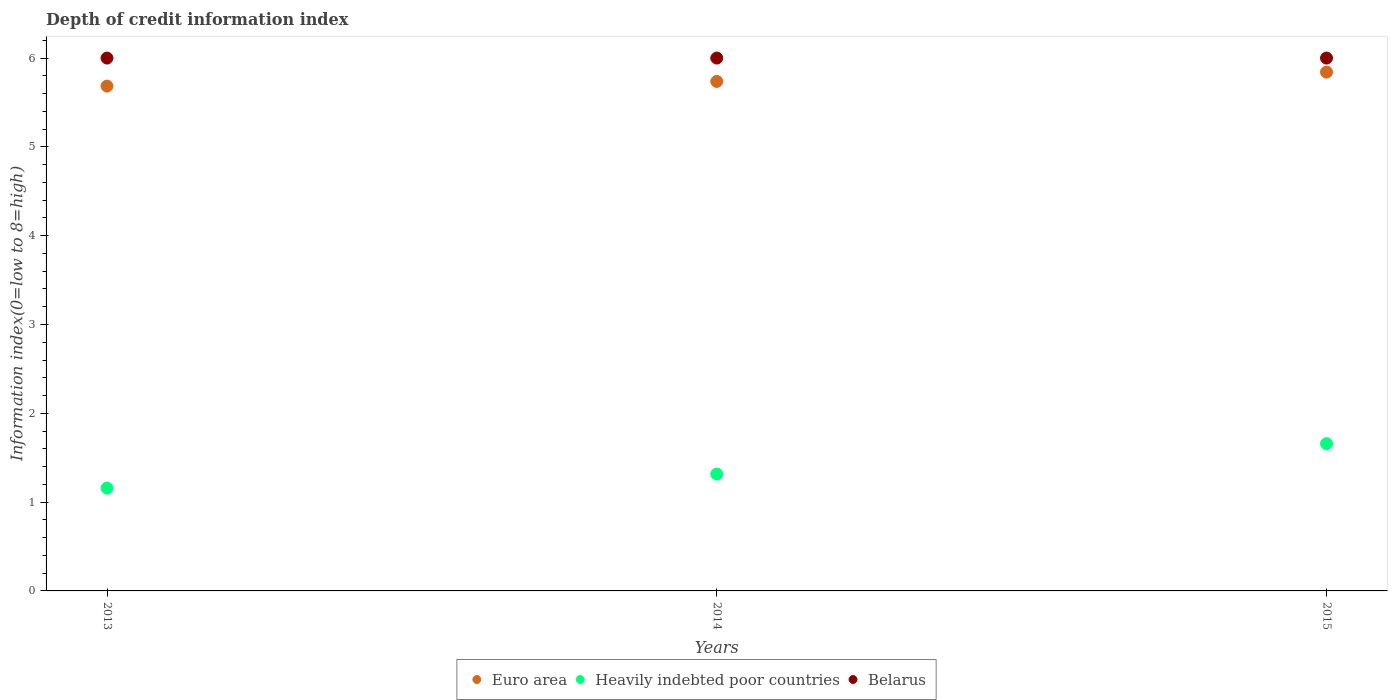How many different coloured dotlines are there?
Provide a short and direct response. 3. What is the information index in Euro area in 2015?
Keep it short and to the point. 5.84. Across all years, what is the maximum information index in Euro area?
Your response must be concise. 5.84. Across all years, what is the minimum information index in Euro area?
Your answer should be very brief. 5.68. In which year was the information index in Euro area maximum?
Your response must be concise. 2015. In which year was the information index in Heavily indebted poor countries minimum?
Offer a terse response. 2013. What is the total information index in Euro area in the graph?
Offer a very short reply. 17.26. What is the difference between the information index in Euro area in 2013 and that in 2014?
Your response must be concise. -0.05. What is the difference between the information index in Heavily indebted poor countries in 2015 and the information index in Belarus in 2014?
Offer a terse response. -4.34. In the year 2013, what is the difference between the information index in Heavily indebted poor countries and information index in Euro area?
Offer a terse response. -4.53. What is the ratio of the information index in Heavily indebted poor countries in 2013 to that in 2015?
Offer a terse response. 0.7. Is the information index in Euro area in 2013 less than that in 2014?
Keep it short and to the point. Yes. What is the difference between the highest and the lowest information index in Euro area?
Make the answer very short. 0.16. In how many years, is the information index in Euro area greater than the average information index in Euro area taken over all years?
Provide a succinct answer. 1. Is the sum of the information index in Heavily indebted poor countries in 2013 and 2015 greater than the maximum information index in Euro area across all years?
Ensure brevity in your answer.  No. Is it the case that in every year, the sum of the information index in Belarus and information index in Euro area  is greater than the information index in Heavily indebted poor countries?
Provide a succinct answer. Yes. Does the information index in Belarus monotonically increase over the years?
Provide a short and direct response. No. Is the information index in Heavily indebted poor countries strictly less than the information index in Euro area over the years?
Provide a succinct answer. Yes. How many dotlines are there?
Ensure brevity in your answer.  3. How many years are there in the graph?
Keep it short and to the point. 3. Are the values on the major ticks of Y-axis written in scientific E-notation?
Offer a terse response. No. Does the graph contain any zero values?
Give a very brief answer. No. Does the graph contain grids?
Keep it short and to the point. No. What is the title of the graph?
Offer a very short reply. Depth of credit information index. Does "Caribbean small states" appear as one of the legend labels in the graph?
Provide a succinct answer. No. What is the label or title of the X-axis?
Give a very brief answer. Years. What is the label or title of the Y-axis?
Give a very brief answer. Information index(0=low to 8=high). What is the Information index(0=low to 8=high) in Euro area in 2013?
Offer a terse response. 5.68. What is the Information index(0=low to 8=high) in Heavily indebted poor countries in 2013?
Your answer should be compact. 1.16. What is the Information index(0=low to 8=high) of Belarus in 2013?
Offer a terse response. 6. What is the Information index(0=low to 8=high) in Euro area in 2014?
Offer a very short reply. 5.74. What is the Information index(0=low to 8=high) in Heavily indebted poor countries in 2014?
Offer a terse response. 1.32. What is the Information index(0=low to 8=high) of Belarus in 2014?
Your answer should be very brief. 6. What is the Information index(0=low to 8=high) of Euro area in 2015?
Give a very brief answer. 5.84. What is the Information index(0=low to 8=high) of Heavily indebted poor countries in 2015?
Make the answer very short. 1.66. Across all years, what is the maximum Information index(0=low to 8=high) of Euro area?
Ensure brevity in your answer.  5.84. Across all years, what is the maximum Information index(0=low to 8=high) of Heavily indebted poor countries?
Make the answer very short. 1.66. Across all years, what is the maximum Information index(0=low to 8=high) of Belarus?
Ensure brevity in your answer.  6. Across all years, what is the minimum Information index(0=low to 8=high) in Euro area?
Give a very brief answer. 5.68. Across all years, what is the minimum Information index(0=low to 8=high) of Heavily indebted poor countries?
Ensure brevity in your answer.  1.16. Across all years, what is the minimum Information index(0=low to 8=high) of Belarus?
Your response must be concise. 6. What is the total Information index(0=low to 8=high) in Euro area in the graph?
Your answer should be very brief. 17.26. What is the total Information index(0=low to 8=high) in Heavily indebted poor countries in the graph?
Provide a short and direct response. 4.13. What is the difference between the Information index(0=low to 8=high) in Euro area in 2013 and that in 2014?
Provide a succinct answer. -0.05. What is the difference between the Information index(0=low to 8=high) in Heavily indebted poor countries in 2013 and that in 2014?
Make the answer very short. -0.16. What is the difference between the Information index(0=low to 8=high) of Belarus in 2013 and that in 2014?
Provide a short and direct response. 0. What is the difference between the Information index(0=low to 8=high) of Euro area in 2013 and that in 2015?
Offer a very short reply. -0.16. What is the difference between the Information index(0=low to 8=high) of Euro area in 2014 and that in 2015?
Offer a very short reply. -0.11. What is the difference between the Information index(0=low to 8=high) in Heavily indebted poor countries in 2014 and that in 2015?
Offer a very short reply. -0.34. What is the difference between the Information index(0=low to 8=high) of Euro area in 2013 and the Information index(0=low to 8=high) of Heavily indebted poor countries in 2014?
Give a very brief answer. 4.37. What is the difference between the Information index(0=low to 8=high) in Euro area in 2013 and the Information index(0=low to 8=high) in Belarus in 2014?
Make the answer very short. -0.32. What is the difference between the Information index(0=low to 8=high) in Heavily indebted poor countries in 2013 and the Information index(0=low to 8=high) in Belarus in 2014?
Your response must be concise. -4.84. What is the difference between the Information index(0=low to 8=high) in Euro area in 2013 and the Information index(0=low to 8=high) in Heavily indebted poor countries in 2015?
Ensure brevity in your answer.  4.03. What is the difference between the Information index(0=low to 8=high) of Euro area in 2013 and the Information index(0=low to 8=high) of Belarus in 2015?
Ensure brevity in your answer.  -0.32. What is the difference between the Information index(0=low to 8=high) in Heavily indebted poor countries in 2013 and the Information index(0=low to 8=high) in Belarus in 2015?
Provide a short and direct response. -4.84. What is the difference between the Information index(0=low to 8=high) in Euro area in 2014 and the Information index(0=low to 8=high) in Heavily indebted poor countries in 2015?
Keep it short and to the point. 4.08. What is the difference between the Information index(0=low to 8=high) in Euro area in 2014 and the Information index(0=low to 8=high) in Belarus in 2015?
Provide a short and direct response. -0.26. What is the difference between the Information index(0=low to 8=high) in Heavily indebted poor countries in 2014 and the Information index(0=low to 8=high) in Belarus in 2015?
Ensure brevity in your answer.  -4.68. What is the average Information index(0=low to 8=high) of Euro area per year?
Provide a short and direct response. 5.75. What is the average Information index(0=low to 8=high) of Heavily indebted poor countries per year?
Provide a short and direct response. 1.38. What is the average Information index(0=low to 8=high) in Belarus per year?
Keep it short and to the point. 6. In the year 2013, what is the difference between the Information index(0=low to 8=high) in Euro area and Information index(0=low to 8=high) in Heavily indebted poor countries?
Make the answer very short. 4.53. In the year 2013, what is the difference between the Information index(0=low to 8=high) of Euro area and Information index(0=low to 8=high) of Belarus?
Your response must be concise. -0.32. In the year 2013, what is the difference between the Information index(0=low to 8=high) in Heavily indebted poor countries and Information index(0=low to 8=high) in Belarus?
Offer a terse response. -4.84. In the year 2014, what is the difference between the Information index(0=low to 8=high) in Euro area and Information index(0=low to 8=high) in Heavily indebted poor countries?
Offer a terse response. 4.42. In the year 2014, what is the difference between the Information index(0=low to 8=high) in Euro area and Information index(0=low to 8=high) in Belarus?
Provide a succinct answer. -0.26. In the year 2014, what is the difference between the Information index(0=low to 8=high) in Heavily indebted poor countries and Information index(0=low to 8=high) in Belarus?
Offer a terse response. -4.68. In the year 2015, what is the difference between the Information index(0=low to 8=high) in Euro area and Information index(0=low to 8=high) in Heavily indebted poor countries?
Give a very brief answer. 4.18. In the year 2015, what is the difference between the Information index(0=low to 8=high) in Euro area and Information index(0=low to 8=high) in Belarus?
Ensure brevity in your answer.  -0.16. In the year 2015, what is the difference between the Information index(0=low to 8=high) in Heavily indebted poor countries and Information index(0=low to 8=high) in Belarus?
Give a very brief answer. -4.34. What is the ratio of the Information index(0=low to 8=high) of Euro area in 2013 to that in 2014?
Your answer should be compact. 0.99. What is the ratio of the Information index(0=low to 8=high) of Heavily indebted poor countries in 2013 to that in 2014?
Make the answer very short. 0.88. What is the ratio of the Information index(0=low to 8=high) in Belarus in 2013 to that in 2014?
Your response must be concise. 1. What is the ratio of the Information index(0=low to 8=high) in Heavily indebted poor countries in 2013 to that in 2015?
Your answer should be very brief. 0.7. What is the ratio of the Information index(0=low to 8=high) of Heavily indebted poor countries in 2014 to that in 2015?
Offer a very short reply. 0.79. What is the ratio of the Information index(0=low to 8=high) in Belarus in 2014 to that in 2015?
Offer a very short reply. 1. What is the difference between the highest and the second highest Information index(0=low to 8=high) of Euro area?
Provide a short and direct response. 0.11. What is the difference between the highest and the second highest Information index(0=low to 8=high) in Heavily indebted poor countries?
Your answer should be very brief. 0.34. What is the difference between the highest and the second highest Information index(0=low to 8=high) in Belarus?
Keep it short and to the point. 0. What is the difference between the highest and the lowest Information index(0=low to 8=high) of Euro area?
Give a very brief answer. 0.16. What is the difference between the highest and the lowest Information index(0=low to 8=high) of Heavily indebted poor countries?
Offer a very short reply. 0.5. 